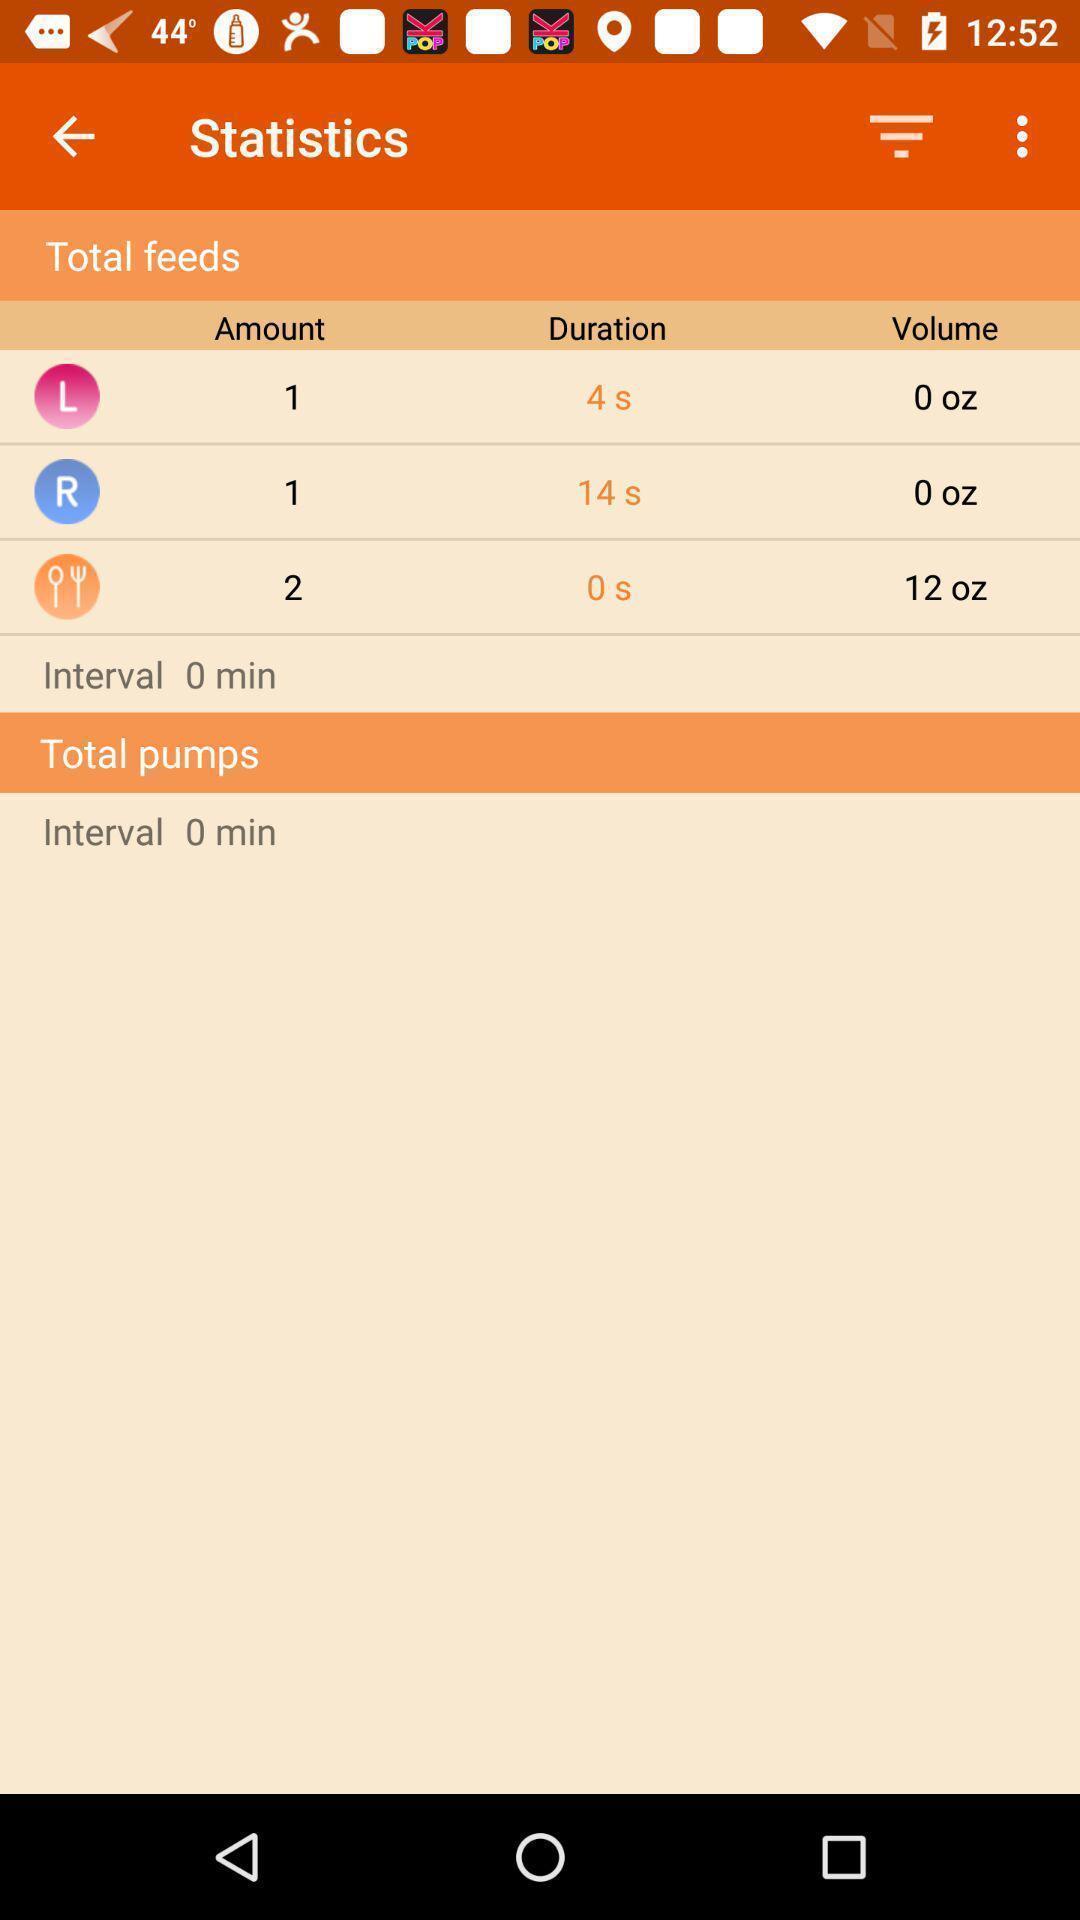Tell me about the visual elements in this screen capture. Page is showing total feeds. 